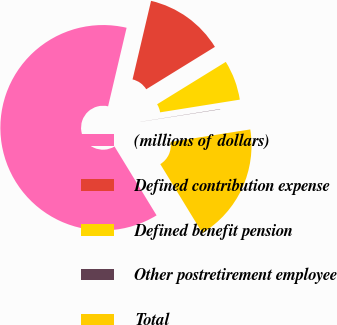Convert chart to OTSL. <chart><loc_0><loc_0><loc_500><loc_500><pie_chart><fcel>(millions of dollars)<fcel>Defined contribution expense<fcel>Defined benefit pension<fcel>Other postretirement employee<fcel>Total<nl><fcel>62.41%<fcel>12.52%<fcel>6.28%<fcel>0.04%<fcel>18.75%<nl></chart> 